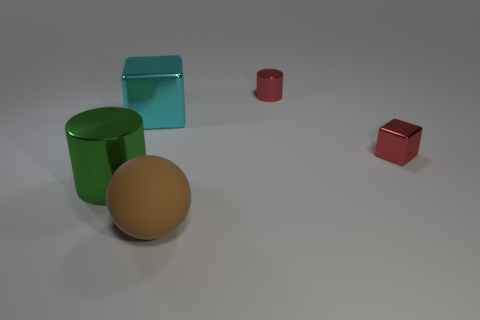Add 1 brown things. How many objects exist? 6 Subtract all spheres. How many objects are left? 4 Add 5 small red metallic cubes. How many small red metallic cubes are left? 6 Add 2 small green matte spheres. How many small green matte spheres exist? 2 Subtract 0 blue cylinders. How many objects are left? 5 Subtract all big purple rubber spheres. Subtract all big blocks. How many objects are left? 4 